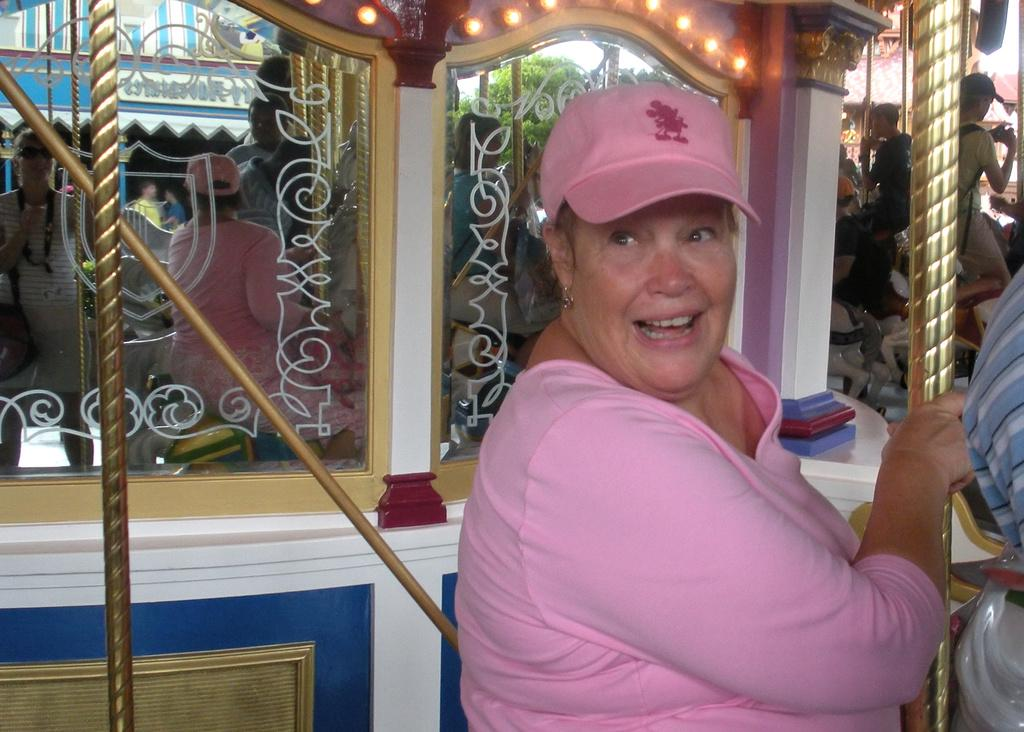Who is the main subject in the picture? There is an old woman in the picture. What is the woman wearing? The woman is wearing a pink dress and a cap. What is the woman's facial expression? The woman is smiling. What is the woman doing in the picture? The woman is giving a pose. What can be seen in the background of the picture? There is a glass mirror, windows with decorative lights, and golden pipes in the background. Can you see a zipper on the woman's pink dress in the image? There is no mention of a zipper on the woman's pink dress in the provided facts, so it cannot be determined from the image. 